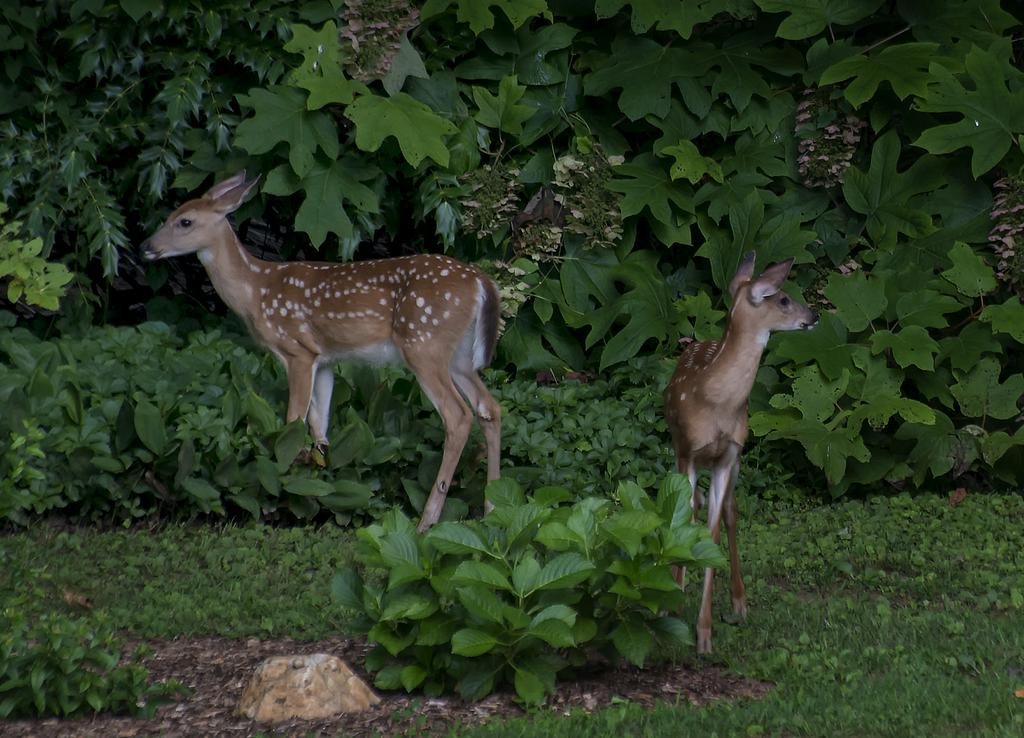What animals are in the center of the image? There are deers in the center of the image. What type of vegetation is at the bottom of the image? There are shrubs at the bottom of the image. What can be seen in the background of the image? There are bushes in the background of the image. What type of bird can be seen in the image? There are no birds present in the image. 